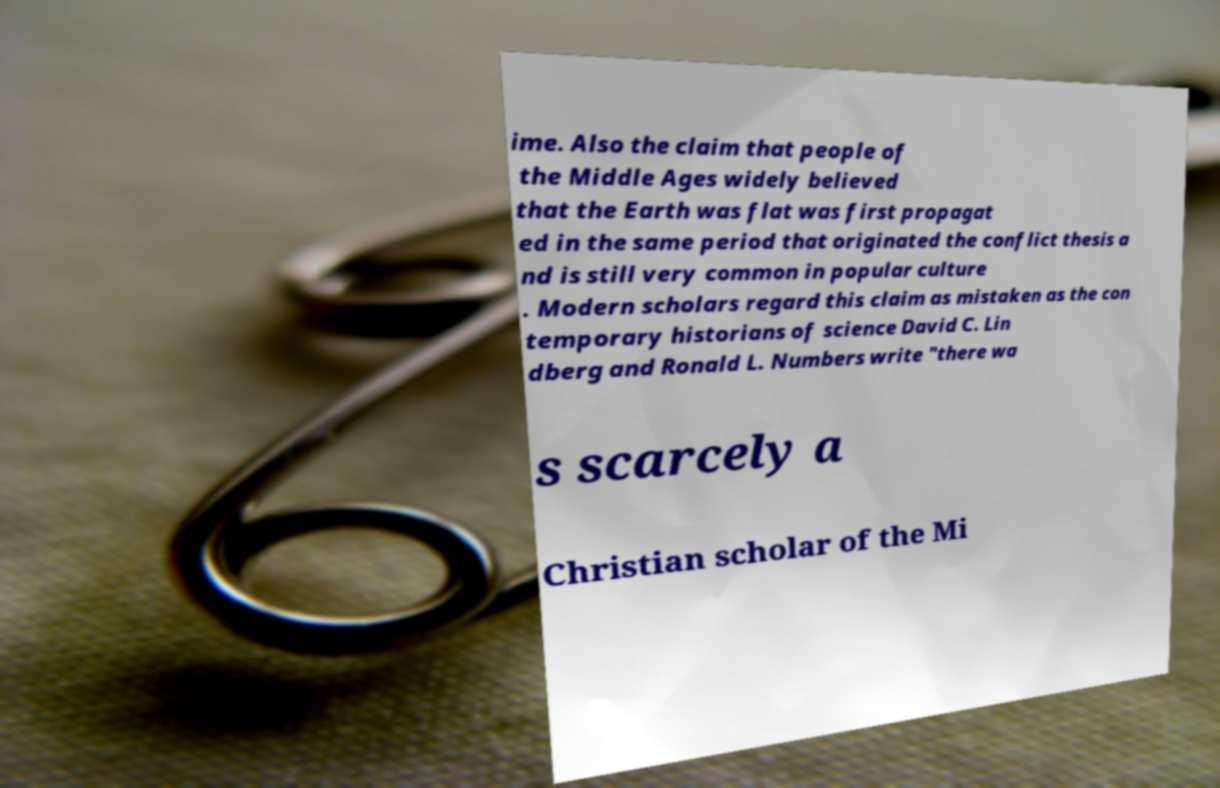Could you assist in decoding the text presented in this image and type it out clearly? ime. Also the claim that people of the Middle Ages widely believed that the Earth was flat was first propagat ed in the same period that originated the conflict thesis a nd is still very common in popular culture . Modern scholars regard this claim as mistaken as the con temporary historians of science David C. Lin dberg and Ronald L. Numbers write "there wa s scarcely a Christian scholar of the Mi 